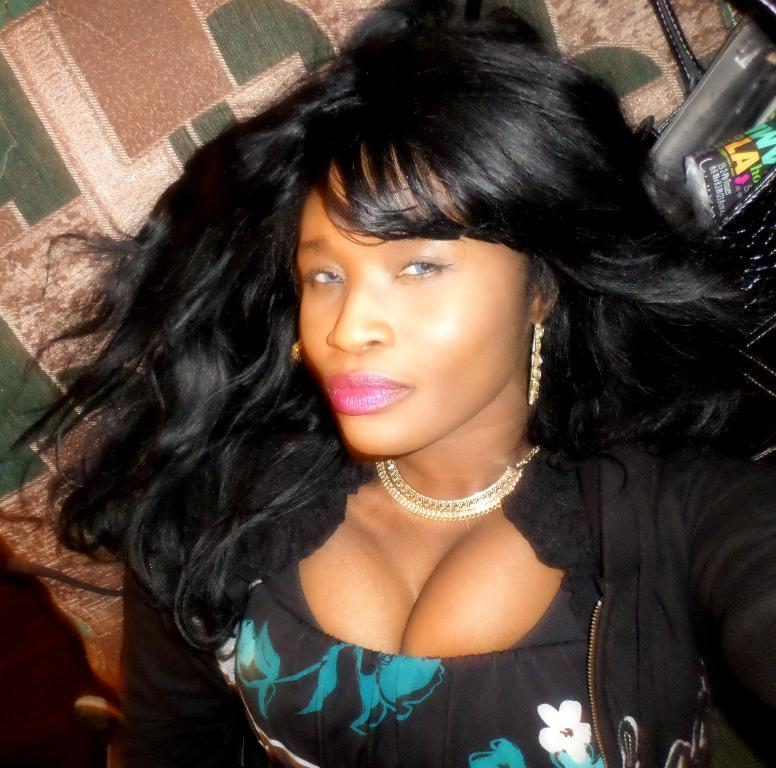Who is the main subject in the image? There is a woman in the image. What is the woman wearing? The woman is wearing a black dress. What is the woman doing in the image? The woman is sitting on a sofa. Are there any other objects on the sofa? Yes, there are other objects on the sofa. What type of fiction is the woman reading on the sofa? There is no book or any form of fiction present in the image. 